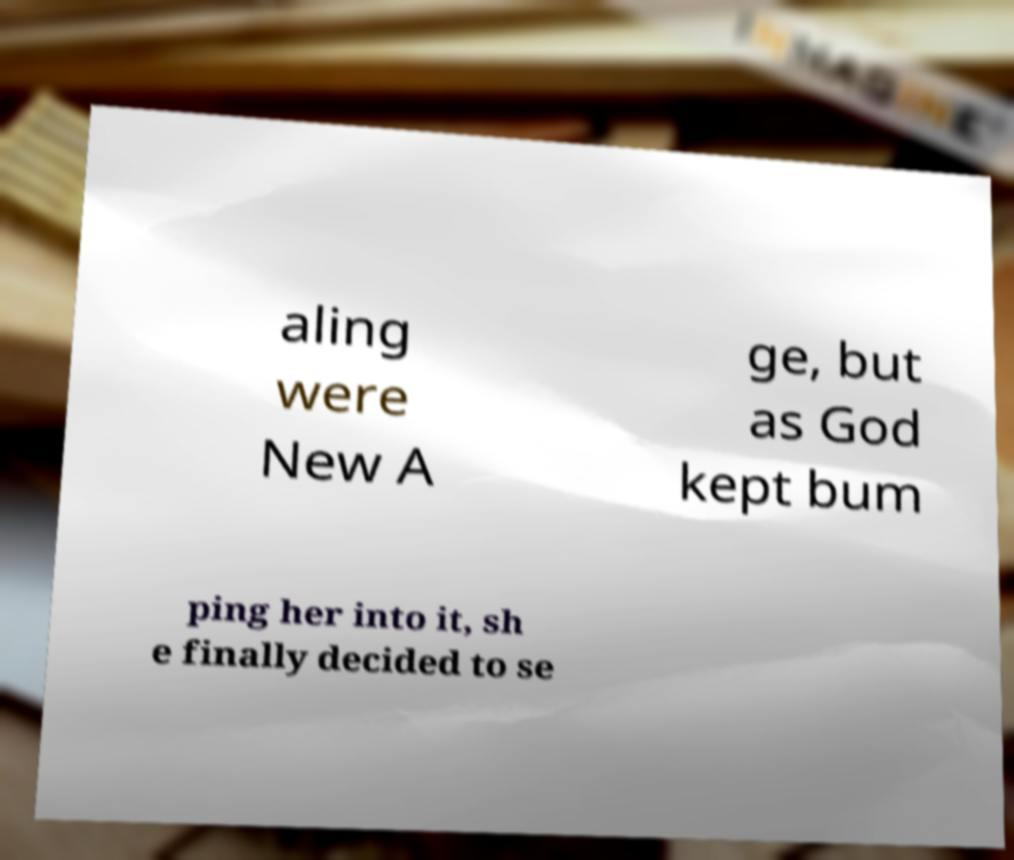I need the written content from this picture converted into text. Can you do that? aling were New A ge, but as God kept bum ping her into it, sh e finally decided to se 